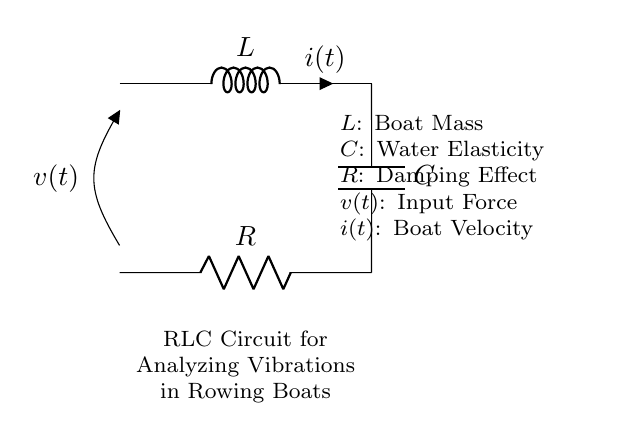What component is represented by "L"? The component "L" in the circuit represents the inductor, which in this context is labeled as the boat mass. This indicates that it is responsible for storing energy in the form of magnetic fields, relating to the inertia of the boat.
Answer: Boat Mass What does "R" represent in the circuit? The "R" in the circuit represents the resistor, which is identified as the damping effect in this scenario. It dissipates energy and influences how vibrations are damped over time, simulating energy losses in the rowing boat.
Answer: Damping Effect What is the input variable denoted by "v(t)"? The "v(t)" in the circuit diagram signifies the input force applied to the system, affecting how the vibrations in the boat are initiated. It represents the external driving force acting on the boat during rowing.
Answer: Input Force What is the role of the capacitor "C" in this context? The capacitor "C" in the circuit is labeled as having an elasticity role, related to the water’s elasticity. It stores energy in the electric field and influences the vibrational behavior of the system, allowing for oscillations at certain frequencies.
Answer: Water Elasticity How are the components "L", "C", and "R" connected in this circuit? The components are connected in a series configuration. The inductor "L" is connected to the capacitor "C", which in turn is connected to the resistor "R". This typical RLC series arrangement shapes how the vibrations propagate through the system.
Answer: Series Connection What happens to vibrations if the resistance "R" increases? If the resistance "R" increases, the damping effect increases, resulting in reduced amplitude of vibrations over time. This leads to quicker dissipation of energy, thereby lessening the oscillatory response of the system.
Answer: Reduced Amplitude What type of circuit configuration is represented here? This is a parallel RLC circuit configuration, which exhibits both resistive and reactive characteristics. This configuration is typical in analyzing systems with mass, elasticity, and damping, like a rowing boat's vibrational response.
Answer: Parallel RLC Circuit 